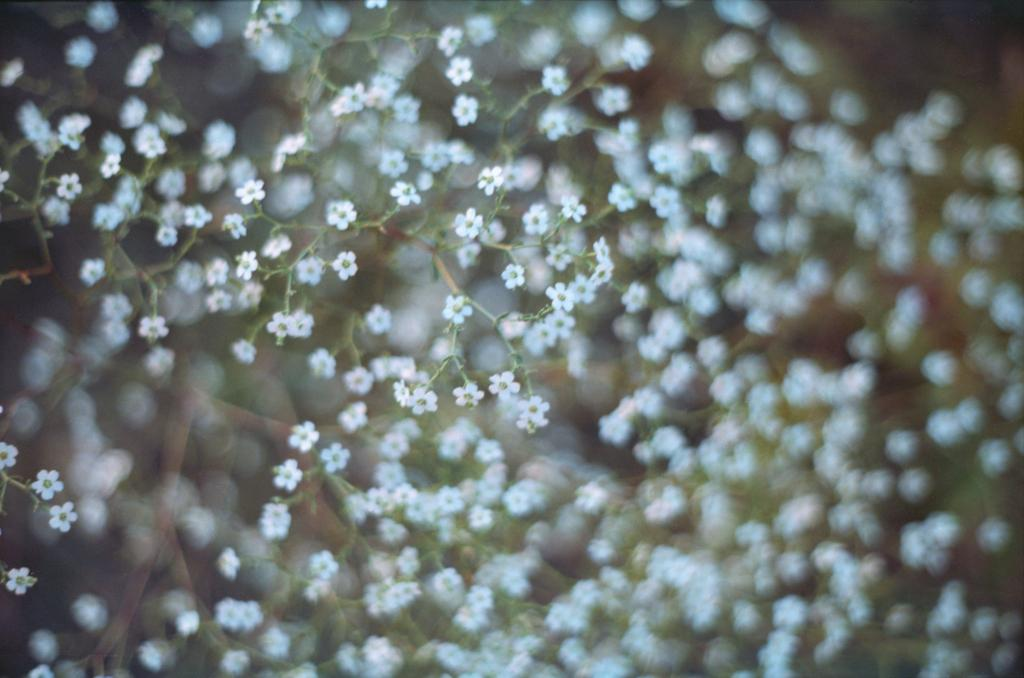What type of flowers are present in the image? The image contains tiny white color flowers. Can you describe the size of the flowers? The flowers are tiny in size. What is the color of the flowers? The flowers are white in color. What type of pleasure can be seen enjoying the flowers in the image? There is no person or creature present in the image to enjoy the flowers, so it is not possible to determine what type of pleasure might be associated with them. 